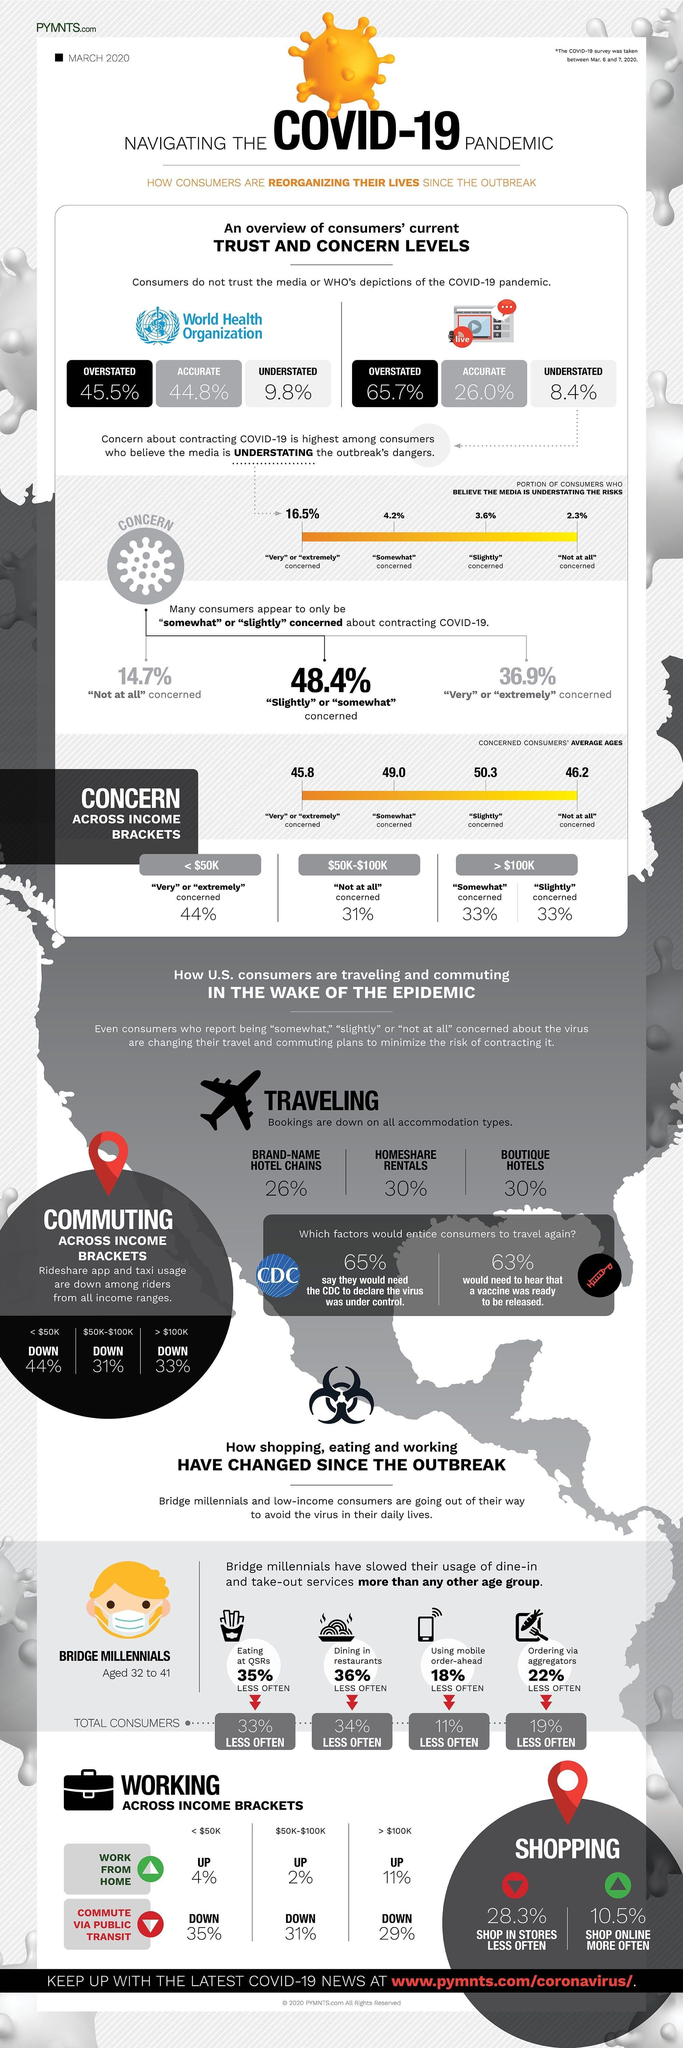Outline some significant characteristics in this image. A recent study found that only 26.0% of media depictions of the COVID-19 pandemic were accurate. According to the study, 44.8% of the COVID-19 pandemic depictions found in popular media were accurate. Individuals who earn over $100,000 per year are least likely to use rideshare apps and taxis. According to the data, the age groups that are somewhat concerned about climate change are primarily those between 49 and 60 years old. A recent survey has revealed that 14.7% of consumers are not at all concerned about contracting COVID-19. 